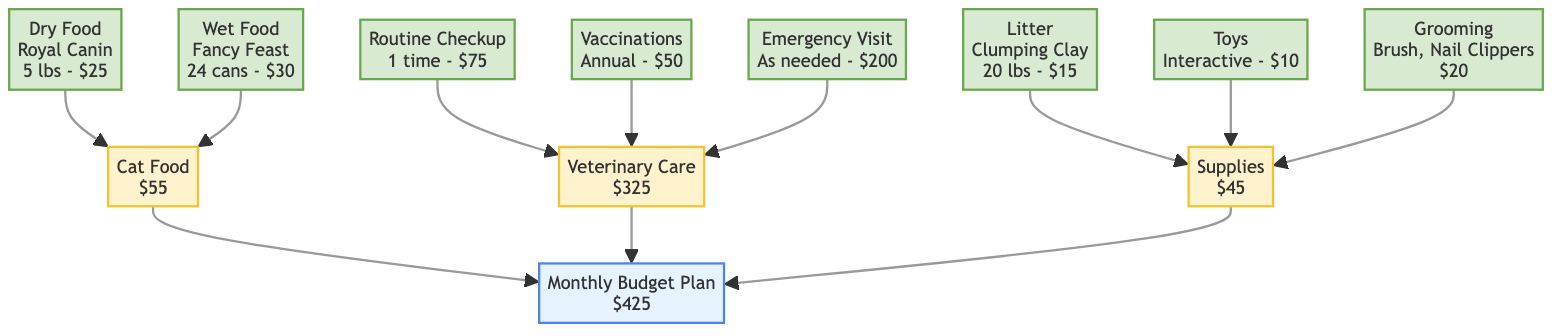What is the total monthly budget for pet expenses? The total monthly budget is represented at the top of the diagram within the Monthly Budget Plan node. It shows a value of $425.
Answer: $425 How much is allocated for veterinary care? The node for Veterinary Care shows a total cost of $325. This amount is directly labeled within that specific node.
Answer: $325 How many types of cat food are listed in the diagram? The Cat Food subcategory has two items listed: Dry Food and Wet Food. By counting these items, we find that there are 2 types.
Answer: 2 What is the estimated cost of an emergency visit? The Emergency Visit node states that the estimated cost is $200. This value is directly found within the node.
Answer: $200 What type of litter is included in the monthly budget plan? In the Supplies category, the Litter node specifies that the type is Clumping Clay. This information is directly mentioned in the Litter node.
Answer: Clumping Clay What is the total cost for grooming supplies? The Grooming node details that the total cost for grooming items (Brush and Nail Clippers) is $20. This information is presented directly within that node.
Answer: $20 Which food brand is listed for wet cat food? The Wet Food node specifies that the brand for wet cat food is Fancy Feast. This information is provided directly in the Wet Food item.
Answer: Fancy Feast If a routine checkup is done once, how much will it cost? The Routine Checkup node indicates that the cost for this service, when done one time, is $75. The answer is derived from the node directly.
Answer: $75 What is the total budget allocated for supplies? The Supplies node states that the total cost allocated for Supplies is $45. This information can be found directly in the Supplies category.
Answer: $45 How many grooming items are included in the budget? The Grooming node lists two items: Brush and Nail Clippers. By counting them, we find that there are 2 items.
Answer: 2 